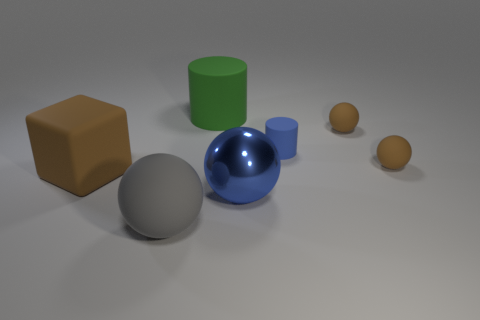There is another metallic object that is the same shape as the gray object; what size is it?
Give a very brief answer. Large. There is a gray matte object; what shape is it?
Provide a succinct answer. Sphere. Is the material of the big brown block the same as the cylinder in front of the big green thing?
Make the answer very short. Yes. How many metal objects are either tiny blue cylinders or large brown cubes?
Make the answer very short. 0. There is a matte cylinder that is left of the big blue object; what size is it?
Provide a succinct answer. Large. The blue cylinder that is made of the same material as the green cylinder is what size?
Provide a short and direct response. Small. What number of tiny rubber spheres have the same color as the block?
Your answer should be compact. 2. Are any tiny brown matte things visible?
Your response must be concise. Yes. There is a tiny blue rubber object; does it have the same shape as the big matte object in front of the matte block?
Your response must be concise. No. What color is the rubber thing in front of the brown matte object that is left of the matte object in front of the shiny object?
Provide a succinct answer. Gray. 